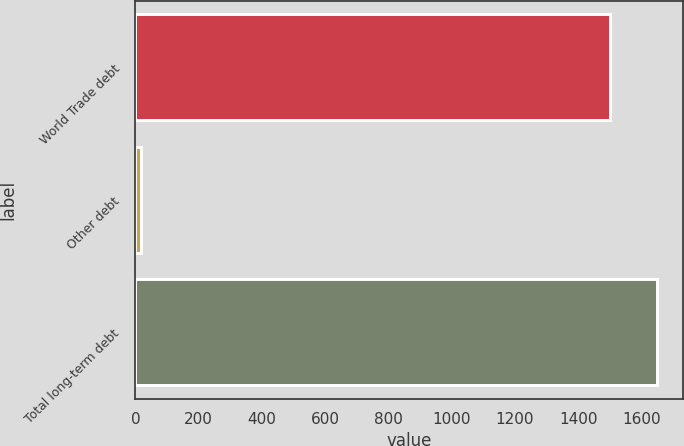Convert chart. <chart><loc_0><loc_0><loc_500><loc_500><bar_chart><fcel>World Trade debt<fcel>Other debt<fcel>Total long-term debt<nl><fcel>1500<fcel>16<fcel>1650<nl></chart> 